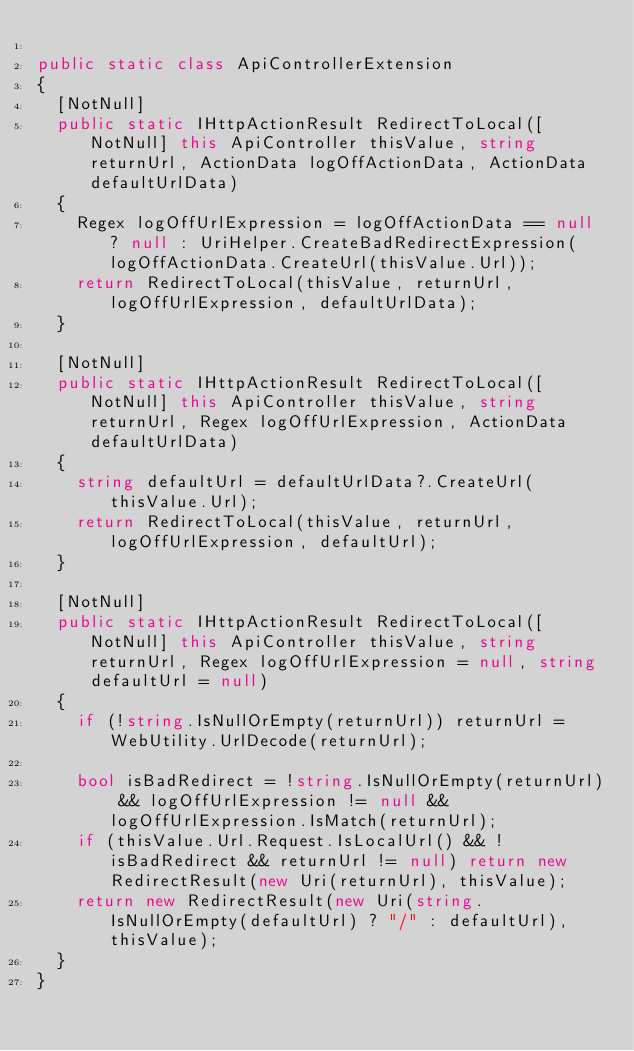<code> <loc_0><loc_0><loc_500><loc_500><_C#_>
public static class ApiControllerExtension
{
	[NotNull]
	public static IHttpActionResult RedirectToLocal([NotNull] this ApiController thisValue, string returnUrl, ActionData logOffActionData, ActionData defaultUrlData)
	{
		Regex logOffUrlExpression = logOffActionData == null ? null : UriHelper.CreateBadRedirectExpression(logOffActionData.CreateUrl(thisValue.Url));
		return RedirectToLocal(thisValue, returnUrl, logOffUrlExpression, defaultUrlData);
	}

	[NotNull]
	public static IHttpActionResult RedirectToLocal([NotNull] this ApiController thisValue, string returnUrl, Regex logOffUrlExpression, ActionData defaultUrlData)
	{
		string defaultUrl = defaultUrlData?.CreateUrl(thisValue.Url);
		return RedirectToLocal(thisValue, returnUrl, logOffUrlExpression, defaultUrl);
	}

	[NotNull]
	public static IHttpActionResult RedirectToLocal([NotNull] this ApiController thisValue, string returnUrl, Regex logOffUrlExpression = null, string defaultUrl = null)
	{
		if (!string.IsNullOrEmpty(returnUrl)) returnUrl = WebUtility.UrlDecode(returnUrl);

		bool isBadRedirect = !string.IsNullOrEmpty(returnUrl) && logOffUrlExpression != null && logOffUrlExpression.IsMatch(returnUrl);
		if (thisValue.Url.Request.IsLocalUrl() && !isBadRedirect && returnUrl != null) return new RedirectResult(new Uri(returnUrl), thisValue);
		return new RedirectResult(new Uri(string.IsNullOrEmpty(defaultUrl) ? "/" : defaultUrl), thisValue);
	}
}</code> 